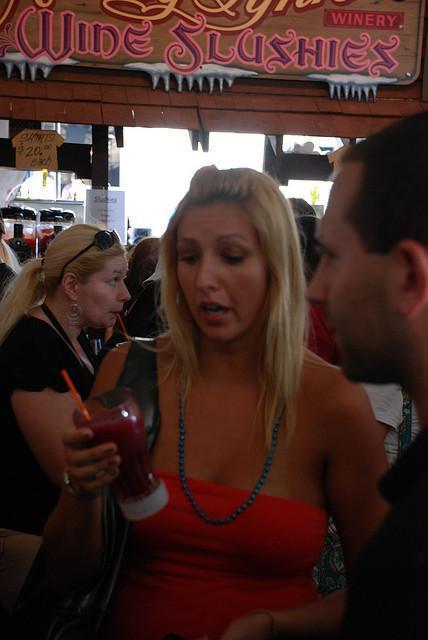Where are these people located?
Pick the correct solution from the four options below to address the question.
Options: Library, hospital, school, winery. Winery. 